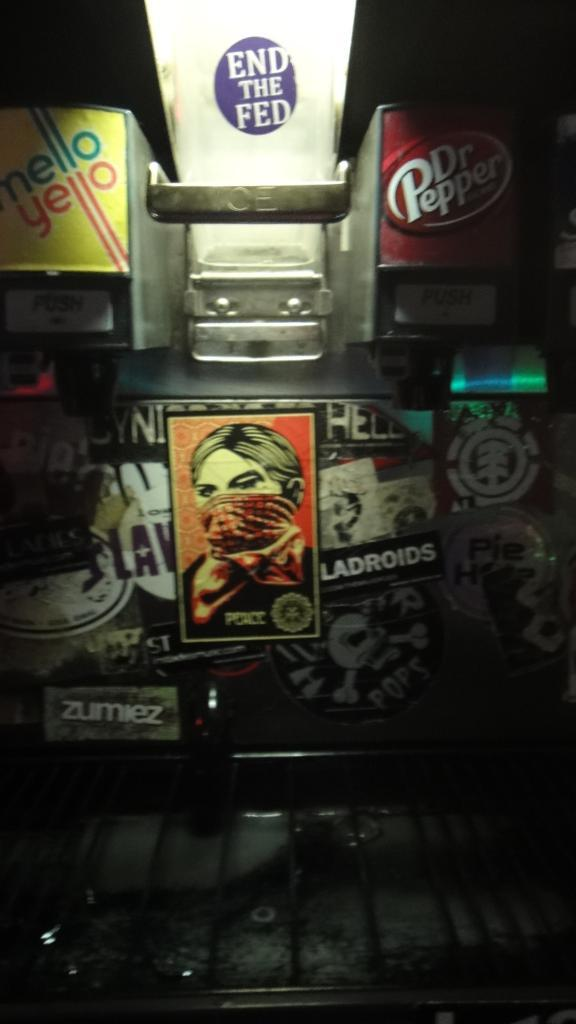Provide a one-sentence caption for the provided image. A fountain drink dispenser that has been sticker bombed with a sticker that says zumiez amoung others. 